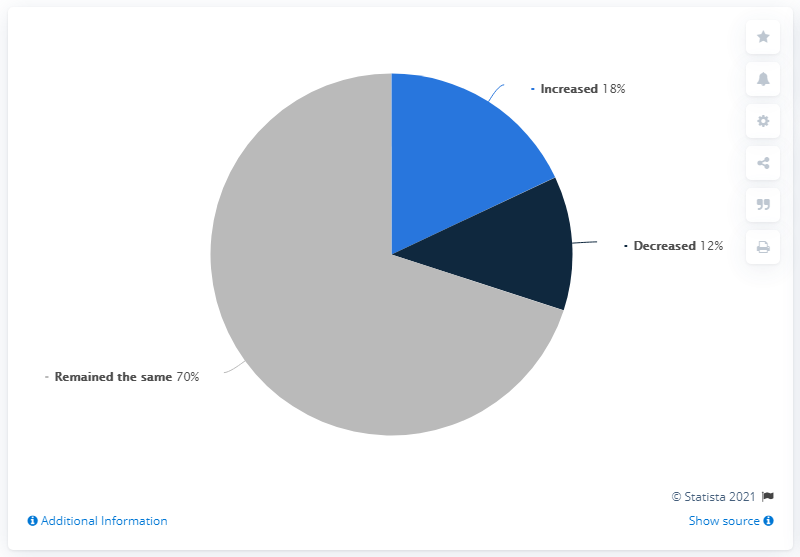Mention a couple of crucial points in this snapshot. The total percentage of decreased and increased values is 30%. The option that dominates the graph is the one that remains the same. 